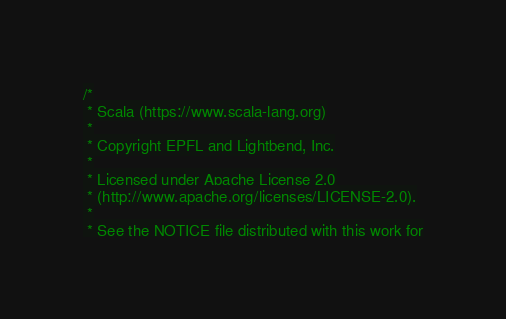Convert code to text. <code><loc_0><loc_0><loc_500><loc_500><_Scala_>/*
 * Scala (https://www.scala-lang.org)
 *
 * Copyright EPFL and Lightbend, Inc.
 *
 * Licensed under Apache License 2.0
 * (http://www.apache.org/licenses/LICENSE-2.0).
 *
 * See the NOTICE file distributed with this work for</code> 